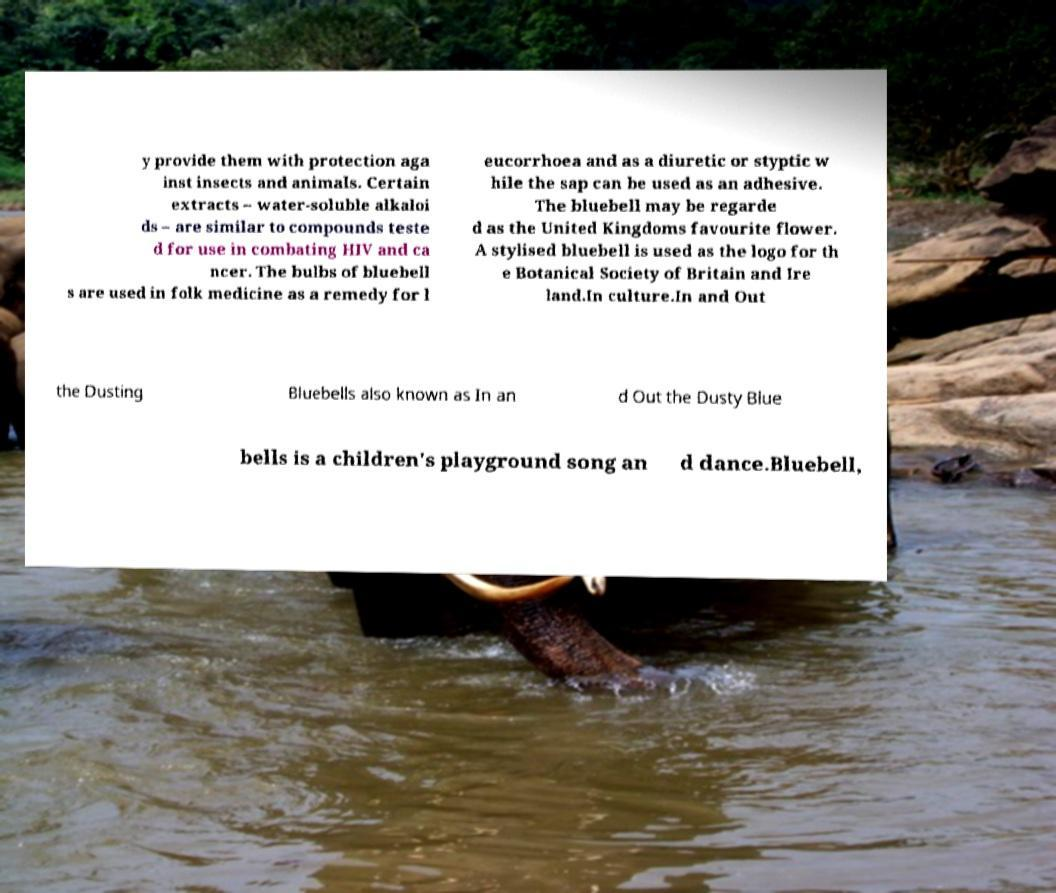Can you accurately transcribe the text from the provided image for me? y provide them with protection aga inst insects and animals. Certain extracts – water-soluble alkaloi ds – are similar to compounds teste d for use in combating HIV and ca ncer. The bulbs of bluebell s are used in folk medicine as a remedy for l eucorrhoea and as a diuretic or styptic w hile the sap can be used as an adhesive. The bluebell may be regarde d as the United Kingdoms favourite flower. A stylised bluebell is used as the logo for th e Botanical Society of Britain and Ire land.In culture.In and Out the Dusting Bluebells also known as In an d Out the Dusty Blue bells is a children's playground song an d dance.Bluebell, 